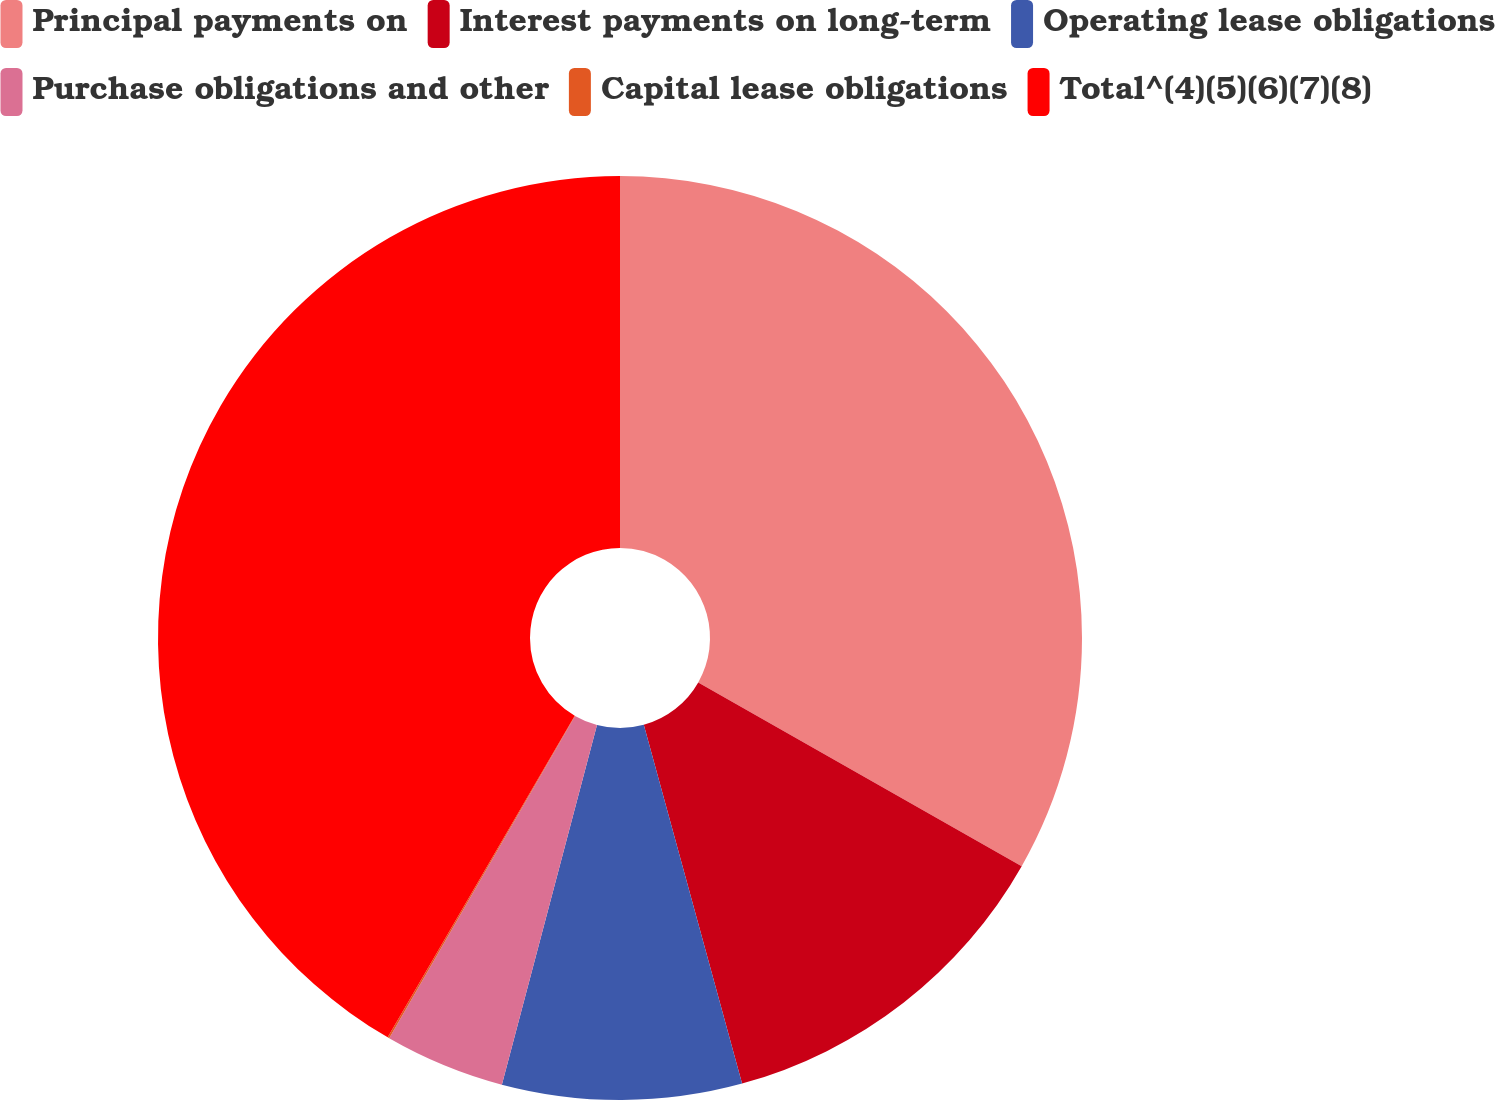Convert chart to OTSL. <chart><loc_0><loc_0><loc_500><loc_500><pie_chart><fcel>Principal payments on<fcel>Interest payments on long-term<fcel>Operating lease obligations<fcel>Purchase obligations and other<fcel>Capital lease obligations<fcel>Total^(4)(5)(6)(7)(8)<nl><fcel>33.22%<fcel>12.52%<fcel>8.37%<fcel>4.21%<fcel>0.06%<fcel>41.61%<nl></chart> 